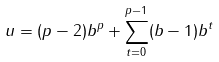Convert formula to latex. <formula><loc_0><loc_0><loc_500><loc_500>u = ( p - 2 ) b ^ { p } + \sum _ { t = 0 } ^ { p - 1 } ( b - 1 ) b ^ { t }</formula> 